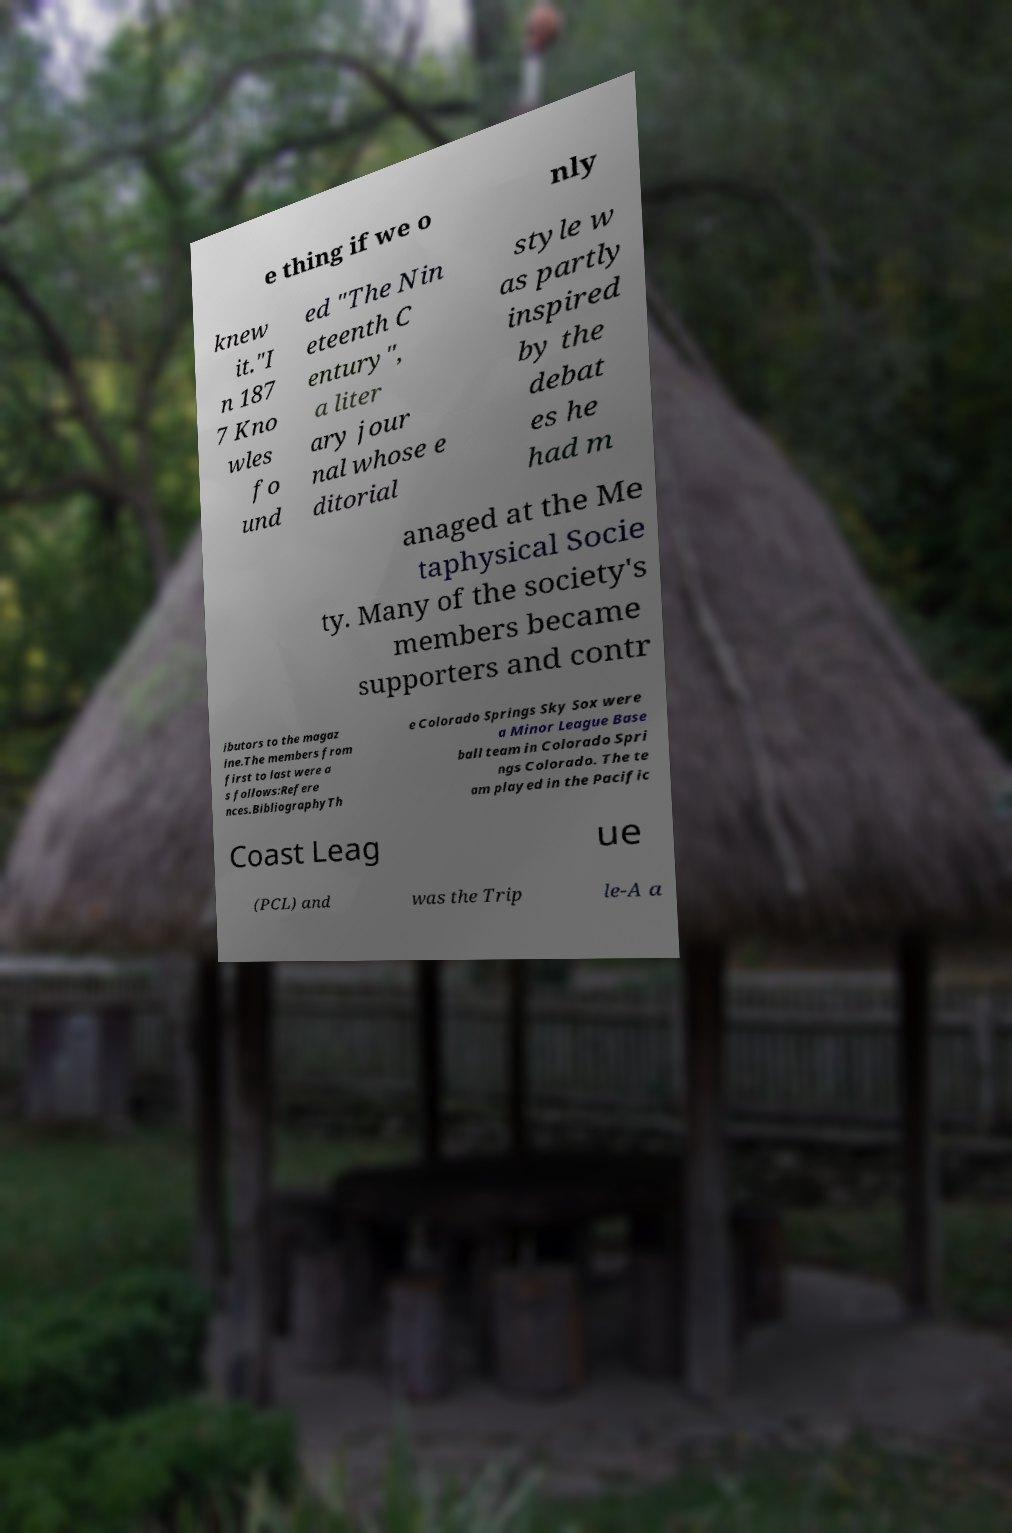Could you assist in decoding the text presented in this image and type it out clearly? e thing if we o nly knew it."I n 187 7 Kno wles fo und ed "The Nin eteenth C entury", a liter ary jour nal whose e ditorial style w as partly inspired by the debat es he had m anaged at the Me taphysical Socie ty. Many of the society's members became supporters and contr ibutors to the magaz ine.The members from first to last were a s follows:Refere nces.BibliographyTh e Colorado Springs Sky Sox were a Minor League Base ball team in Colorado Spri ngs Colorado. The te am played in the Pacific Coast Leag ue (PCL) and was the Trip le-A a 